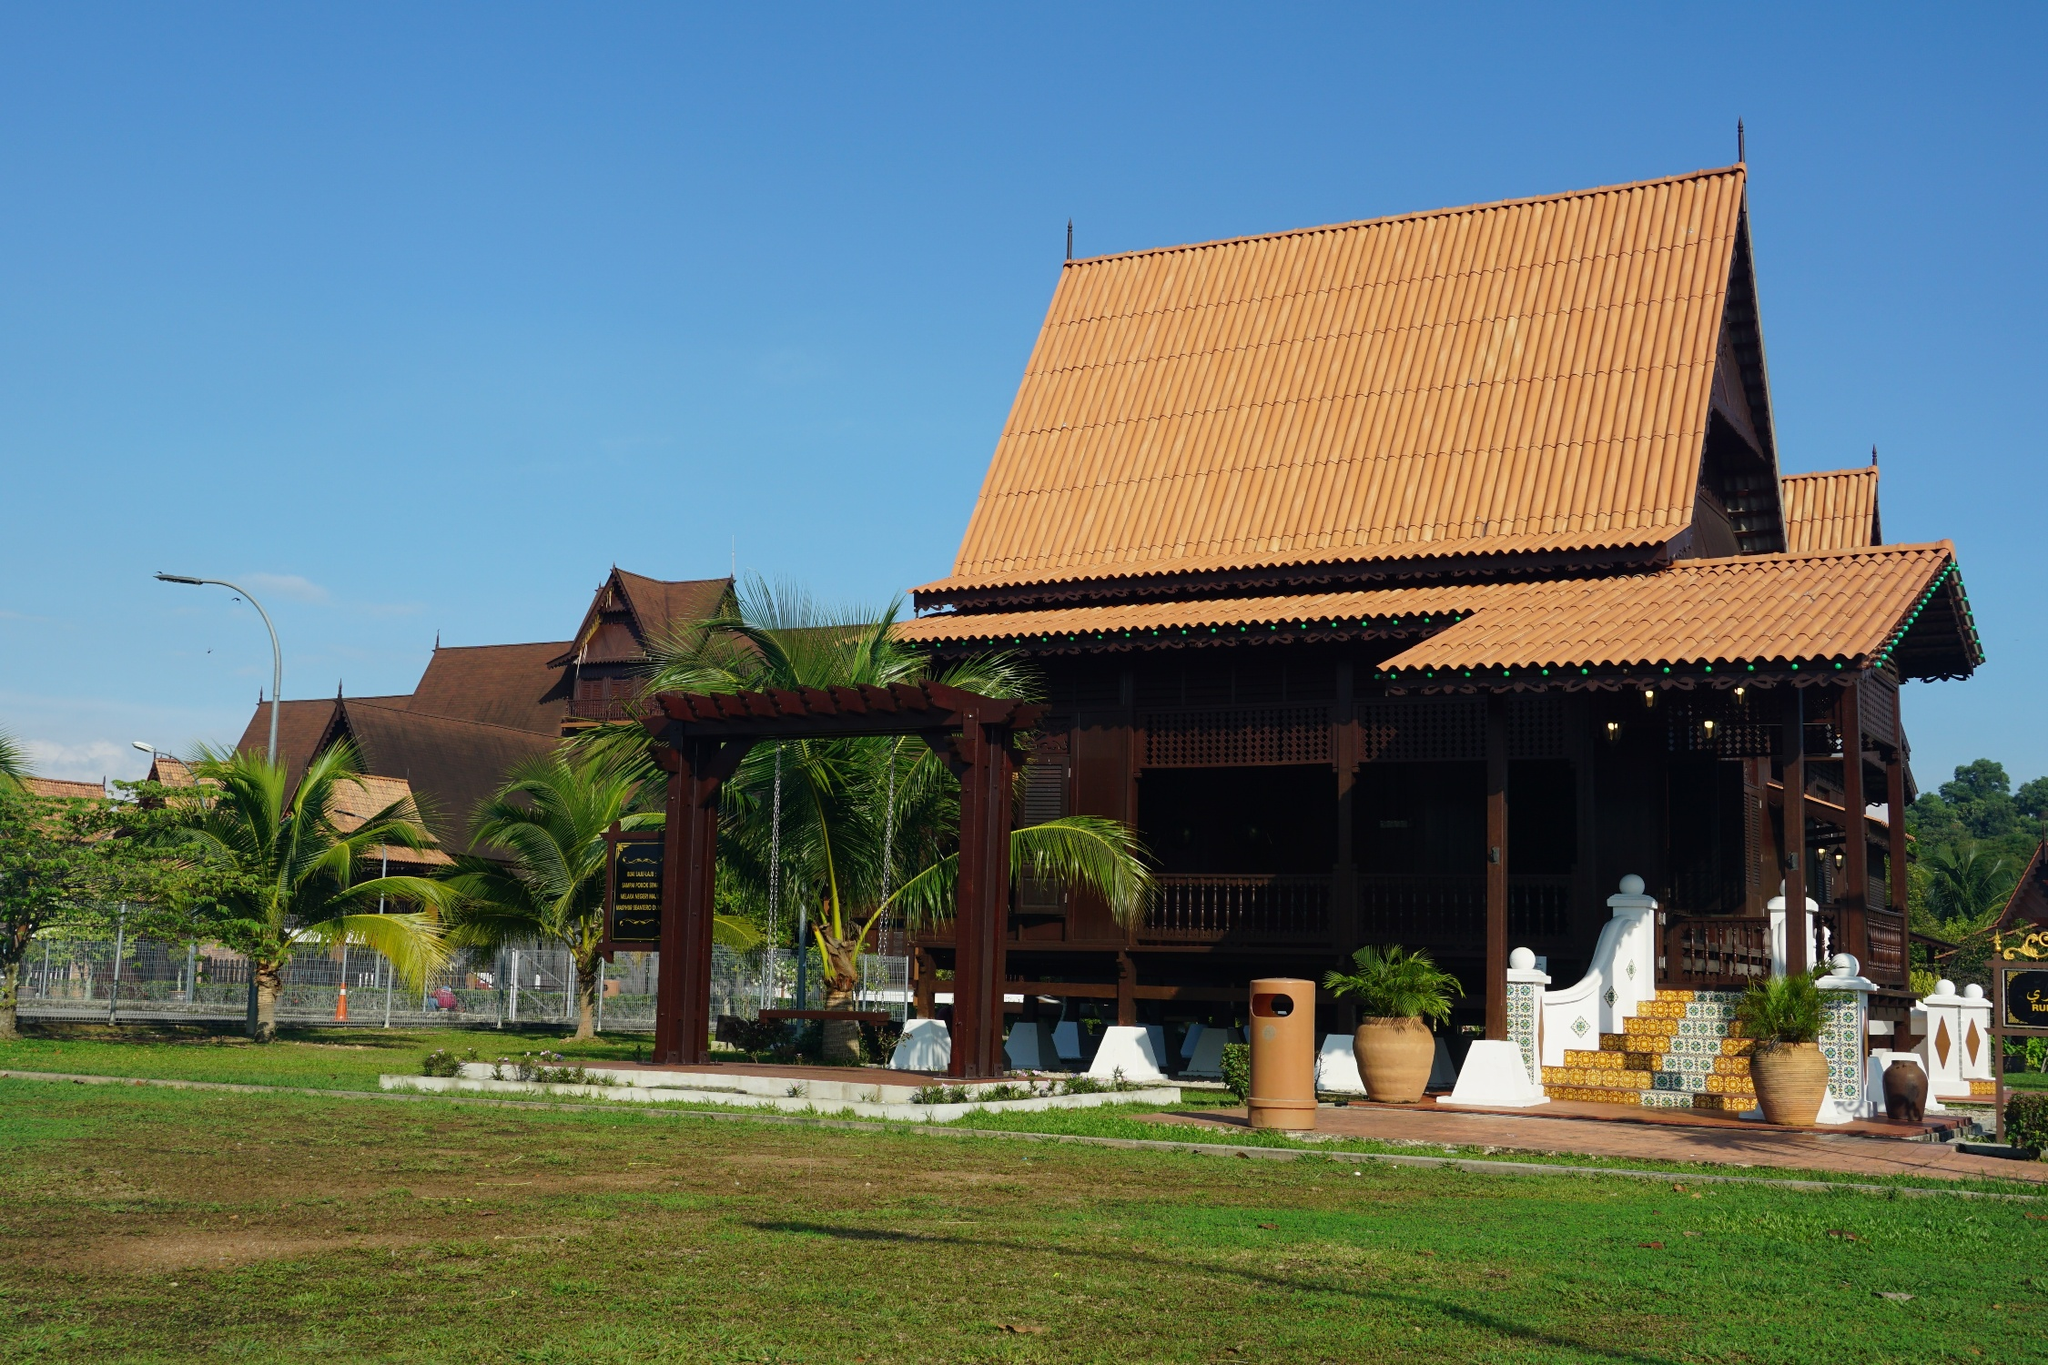Can you describe the atmosphere and surroundings in the image? The atmosphere in the image is serene and tranquil, characterized by the clear blue sky and the bright sunlight casting soft shadows on the lush green lawn. The traditional Thai house is the central focus, with its vibrant red-tiled roof contrasting sharply against the surrounding greenery. Palm trees are scattered around, their fronds swaying gently in the breeze, contributing to a relaxed, tropical ambiance. The presence of meticulously designed pottery and a well-maintained garden hints at a sense of order and pride in the environment. This scene exudes a peaceful, almost idyllic charm, inviting one to leisurely explore and appreciate the delicate blend of nature and architecture. What kind of events or activities might take place in this setting? This serene setting seems ideal for a variety of activities and events. It could host traditional Thai festivals or ceremonies with music, dance, and vibrant attire, highlighting the rich cultural heritage. Family gatherings or community events might be held on the spacious lawn, where people can enjoy picnics, games, and leisurely conversations under the shade of the palm trees. The house's porch and entrance area could serve as a picturesque spot for weddings or other significant celebrations, with the intricate architecture providing a stunning backdrop for photographs. Educational tours showcasing traditional Thai architecture and craftsmanship could also take place here, offering an immersive experience into Thailand's history and culture. 